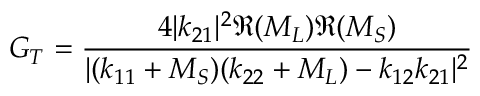Convert formula to latex. <formula><loc_0><loc_0><loc_500><loc_500>G _ { T } = { \frac { 4 | k _ { 2 1 } | ^ { 2 } \Re { ( M _ { L } ) } \Re { ( M _ { S } ) } } { | ( k _ { 1 1 } + M _ { S } ) ( k _ { 2 2 } + M _ { L } ) - k _ { 1 2 } k _ { 2 1 } | ^ { 2 } } }</formula> 